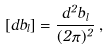Convert formula to latex. <formula><loc_0><loc_0><loc_500><loc_500>[ d b _ { l } ] = \frac { d ^ { 2 } b _ { l } } { ( 2 \pi ) ^ { 2 } } \, ,</formula> 